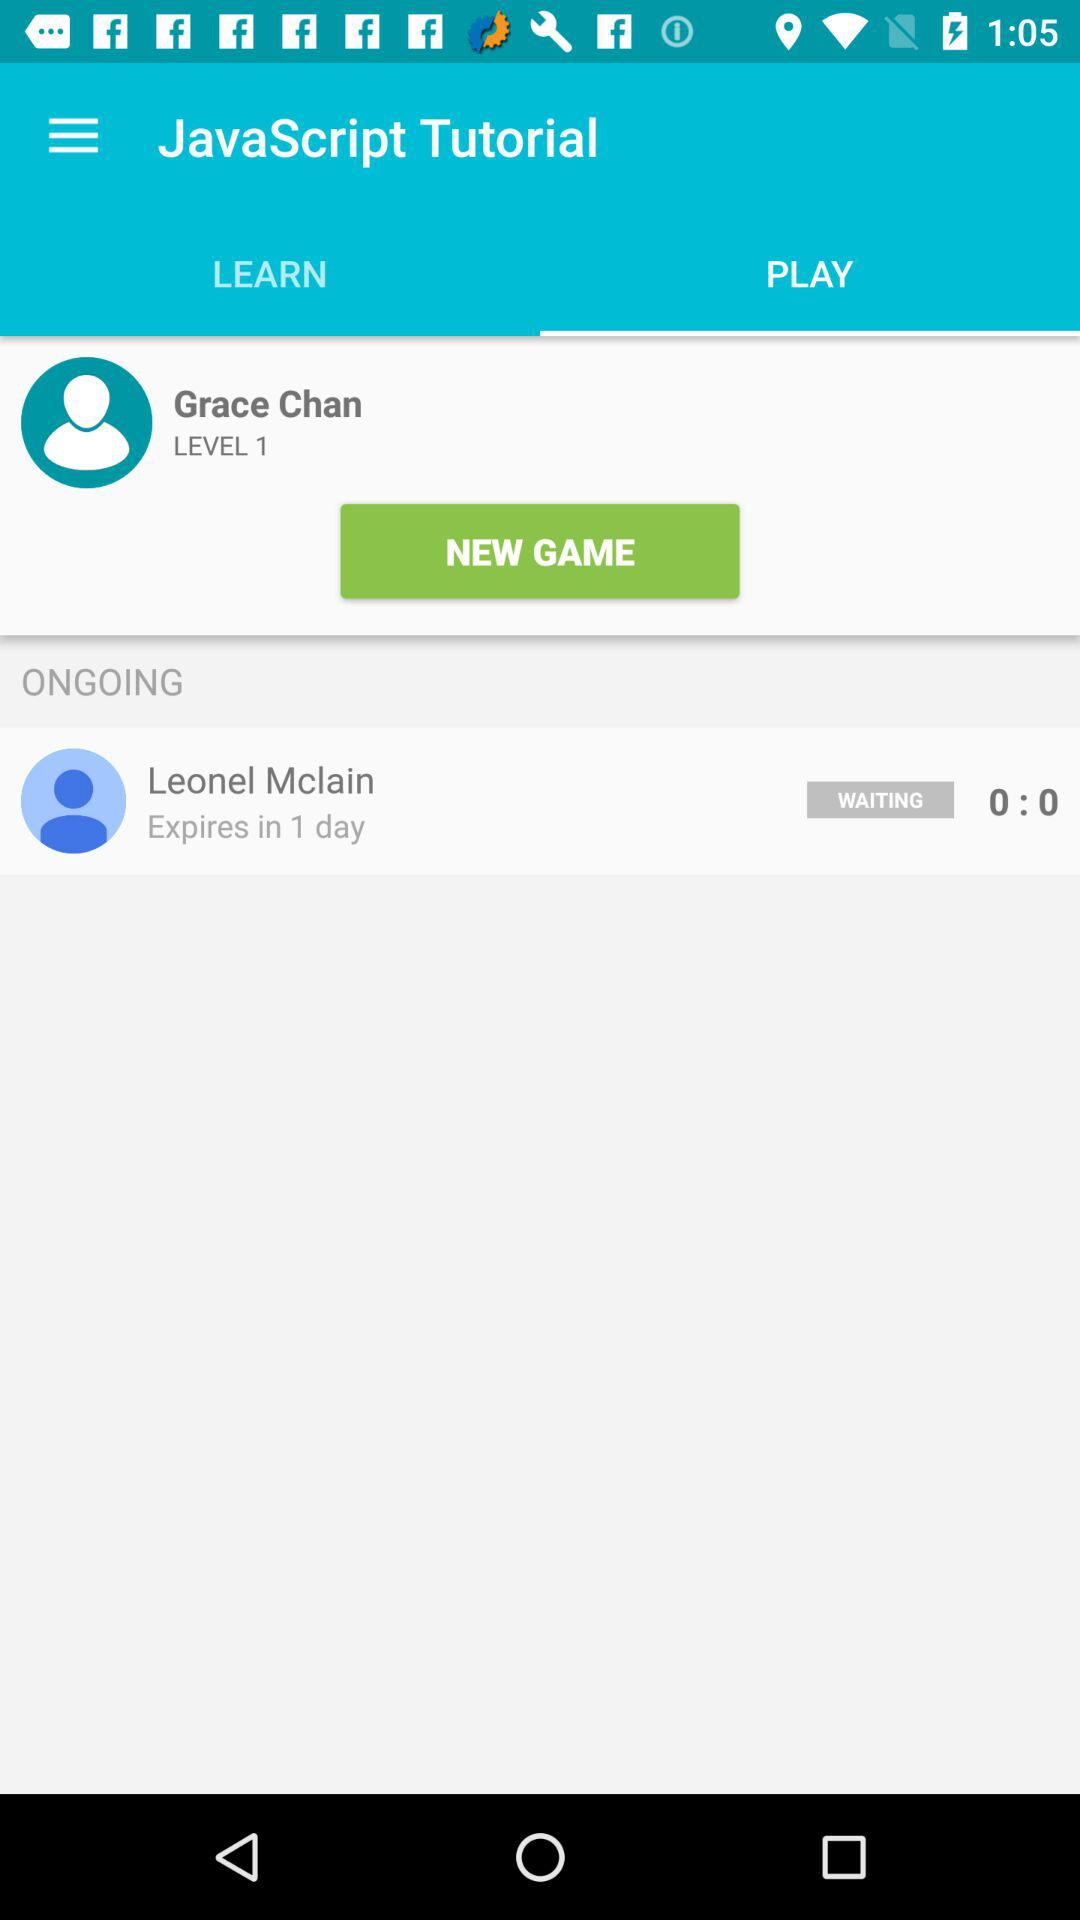What is the duration until Leonel McLain expires? Leonel McLain expires in 1 day. 